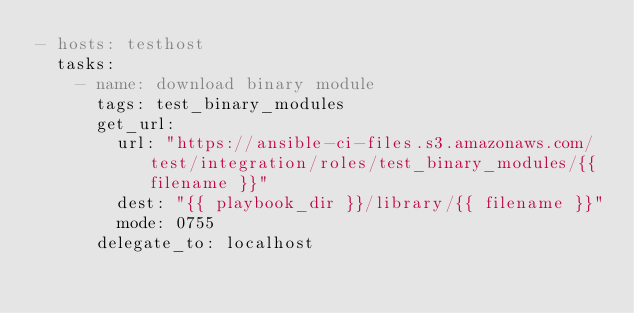Convert code to text. <code><loc_0><loc_0><loc_500><loc_500><_YAML_>- hosts: testhost
  tasks:
    - name: download binary module
      tags: test_binary_modules
      get_url:
        url: "https://ansible-ci-files.s3.amazonaws.com/test/integration/roles/test_binary_modules/{{ filename }}"
        dest: "{{ playbook_dir }}/library/{{ filename }}"
        mode: 0755
      delegate_to: localhost
</code> 